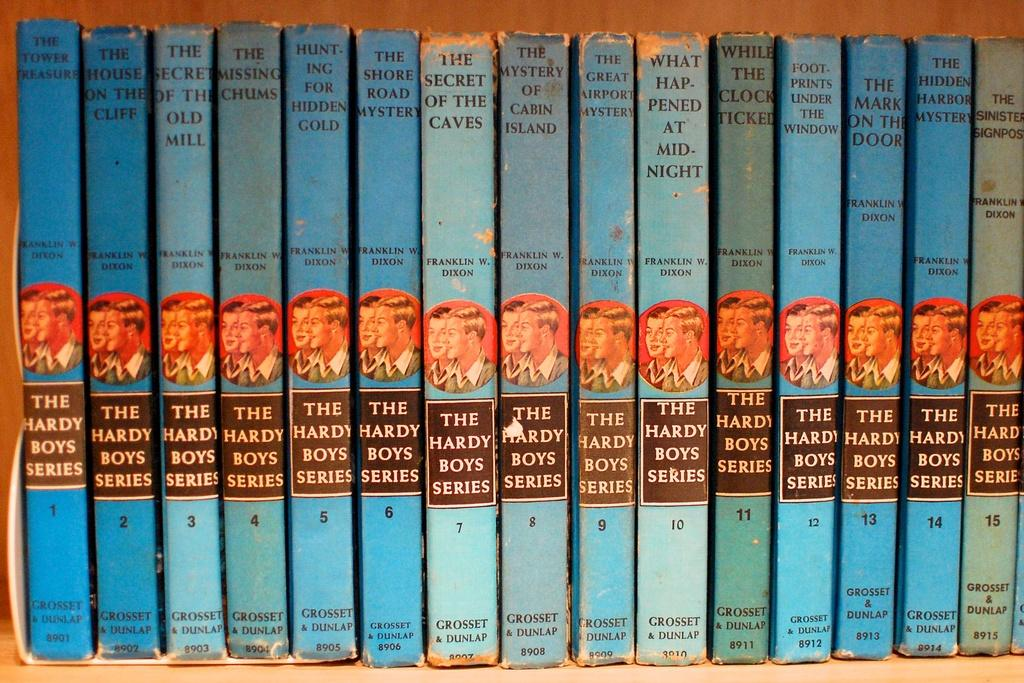<image>
Describe the image concisely. A collection of Hardy Boys mysteries on a shelf includes the title The Secret of the Caves. 